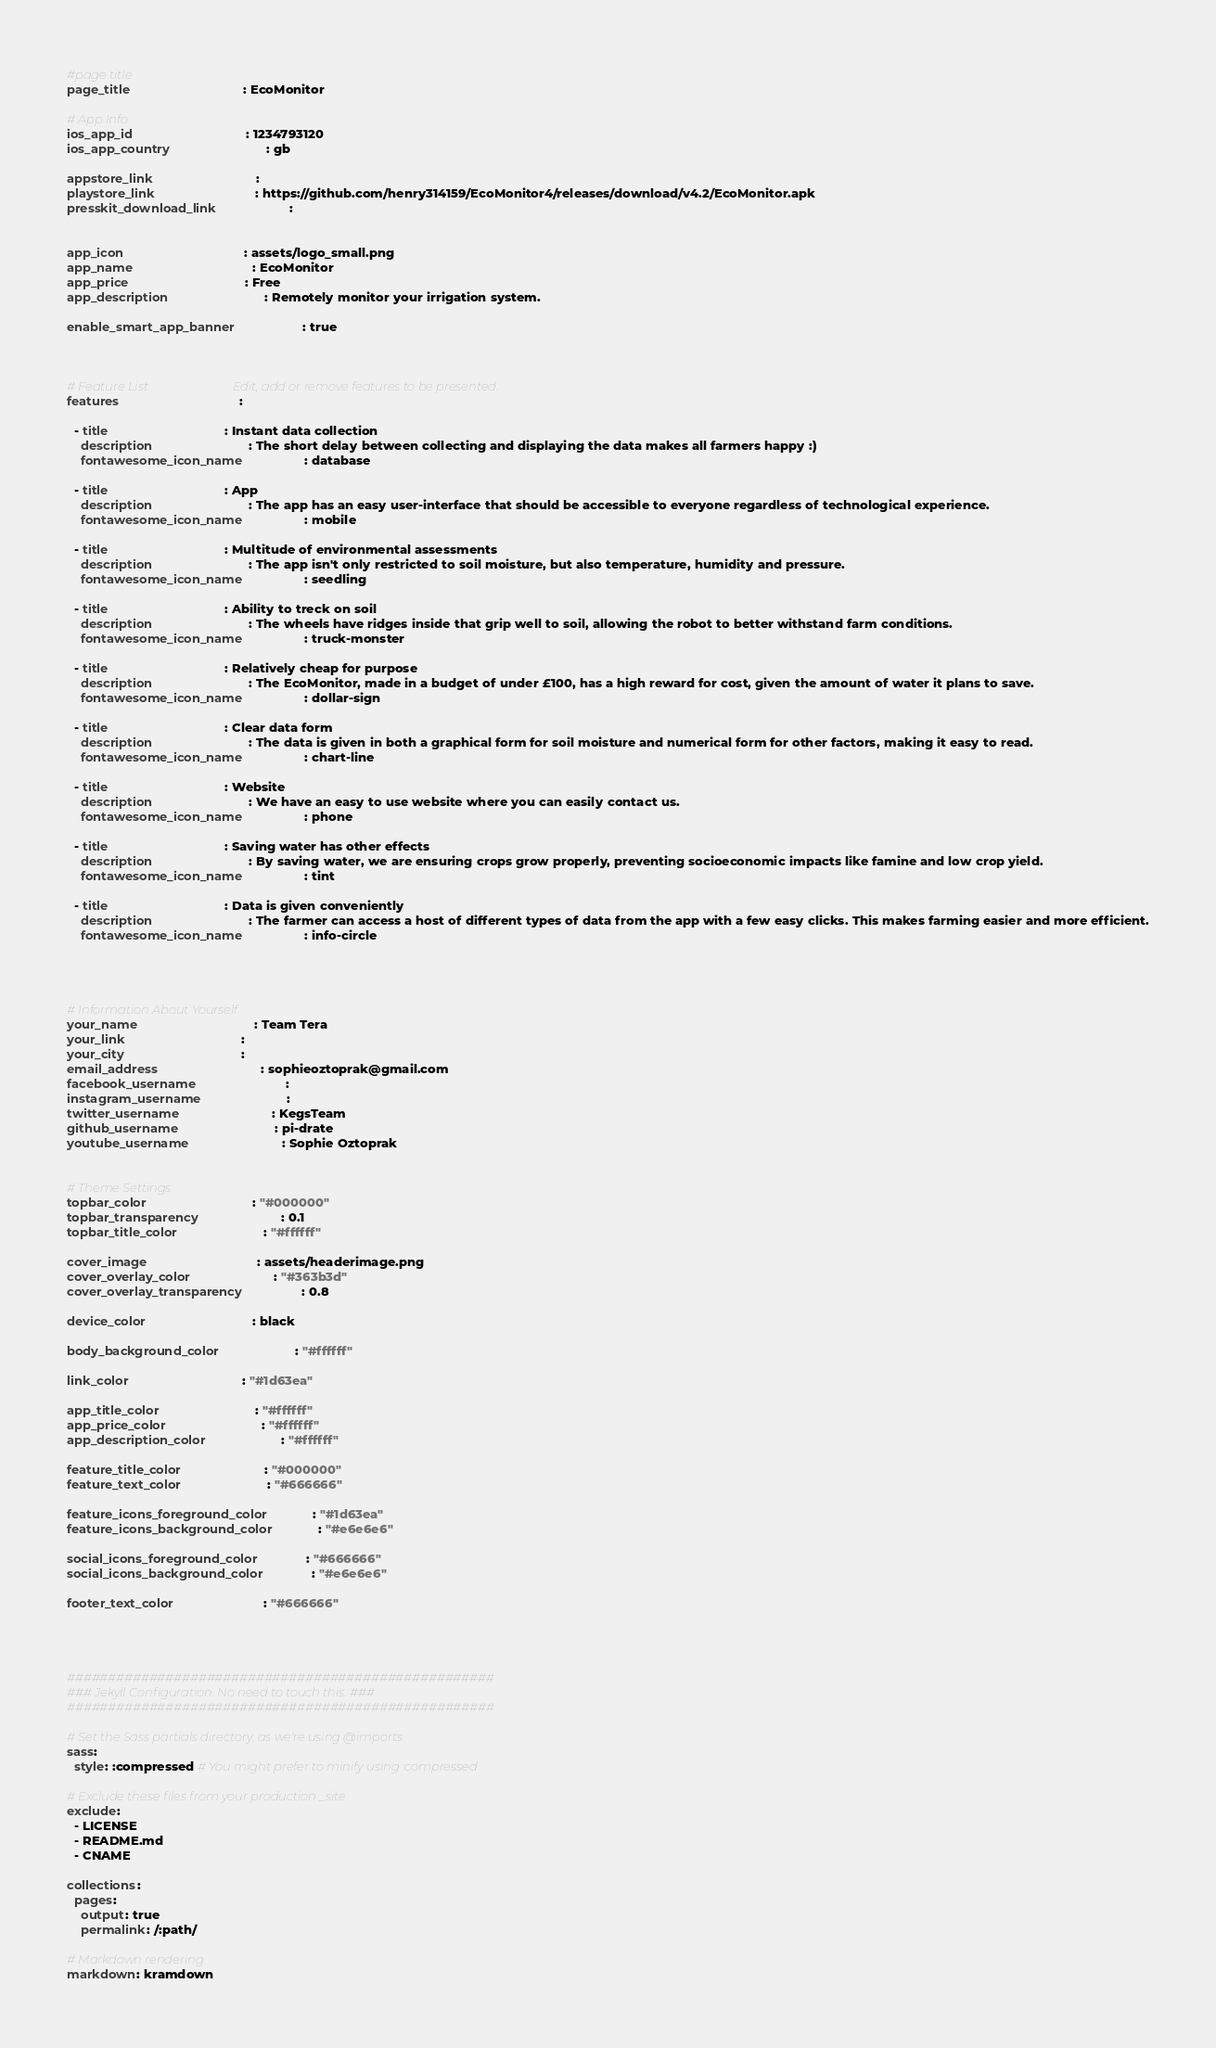Convert code to text. <code><loc_0><loc_0><loc_500><loc_500><_YAML_>#page title
page_title                                : EcoMonitor

# App Info
ios_app_id                                : 1234793120
ios_app_country                           : gb

appstore_link                             :
playstore_link                            : https://github.com/henry314159/EcoMonitor4/releases/download/v4.2/EcoMonitor.apk
presskit_download_link                    : 


app_icon                                  : assets/logo_small.png
app_name                                  : EcoMonitor
app_price                                 : Free
app_description                           : Remotely monitor your irrigation system.

enable_smart_app_banner                   : true



# Feature List                            Edit, add or remove features to be presented.
features                                  :

  - title                                 : Instant data collection
    description                           : The short delay between collecting and displaying the data makes all farmers happy :)
    fontawesome_icon_name                 : database
    
  - title                                 : App
    description                           : The app has an easy user-interface that should be accessible to everyone regardless of technological experience.
    fontawesome_icon_name                 : mobile

  - title                                 : Multitude of environmental assessments
    description                           : The app isn't only restricted to soil moisture, but also temperature, humidity and pressure.
    fontawesome_icon_name                 : seedling

  - title                                 : Ability to treck on soil
    description                           : The wheels have ridges inside that grip well to soil, allowing the robot to better withstand farm conditions.
    fontawesome_icon_name                 : truck-monster

  - title                                 : Relatively cheap for purpose
    description                           : The EcoMonitor, made in a budget of under £100, has a high reward for cost, given the amount of water it plans to save.
    fontawesome_icon_name                 : dollar-sign
  
  - title                                 : Clear data form
    description                           : The data is given in both a graphical form for soil moisture and numerical form for other factors, making it easy to read.
    fontawesome_icon_name                 : chart-line

  - title                                 : Website
    description                           : We have an easy to use website where you can easily contact us.
    fontawesome_icon_name                 : phone

  - title                                 : Saving water has other effects
    description                           : By saving water, we are ensuring crops grow properly, preventing socioeconomic impacts like famine and low crop yield.
    fontawesome_icon_name                 : tint

  - title                                 : Data is given conveniently
    description                           : The farmer can access a host of different types of data from the app with a few easy clicks. This makes farming easier and more efficient.
    fontawesome_icon_name                 : info-circle




# Information About Yourself
your_name                                 : Team Tera                                
your_link                                 :                      
your_city                                 :                             
email_address                             : sophieoztoprak@gmail.com
facebook_username                         :                                           
instagram_username                        : 
twitter_username                          : KegsTeam
github_username                           : pi-drate
youtube_username                          : Sophie Oztoprak


# Theme Settings
topbar_color                              : "#000000"
topbar_transparency                       : 0.1
topbar_title_color                        : "#ffffff"

cover_image                               : assets/headerimage.png
cover_overlay_color                       : "#363b3d"
cover_overlay_transparency                : 0.8

device_color                              : black

body_background_color                     : "#ffffff"

link_color                                : "#1d63ea"

app_title_color                           : "#ffffff"
app_price_color                           : "#ffffff"
app_description_color                     : "#ffffff"

feature_title_color                       : "#000000"
feature_text_color                        : "#666666"

feature_icons_foreground_color            : "#1d63ea"
feature_icons_background_color            : "#e6e6e6"

social_icons_foreground_color             : "#666666"
social_icons_background_color             : "#e6e6e6"

footer_text_color                         : "#666666"




####################################################
### Jekyll Configuration. No need to touch this. ###
####################################################

# Set the Sass partials directory, as we're using @imports
sass:
  style: :compressed # You might prefer to minify using :compressed

# Exclude these files from your production _site
exclude:
  - LICENSE
  - README.md
  - CNAME

collections:
  pages:
    output: true
    permalink: /:path/

# Markdown rendering
markdown: kramdown
</code> 